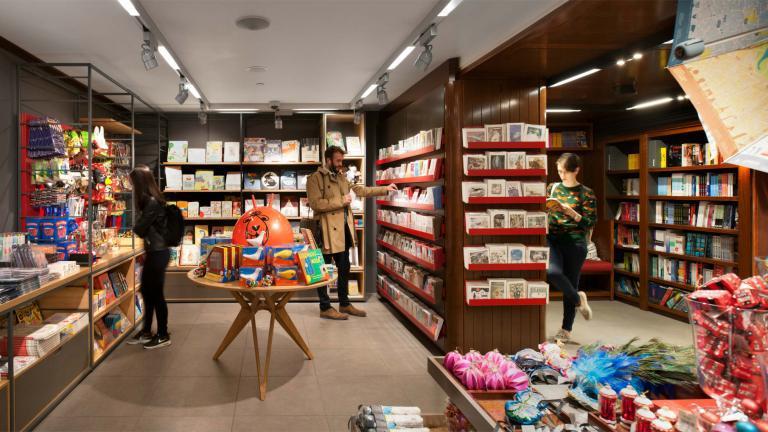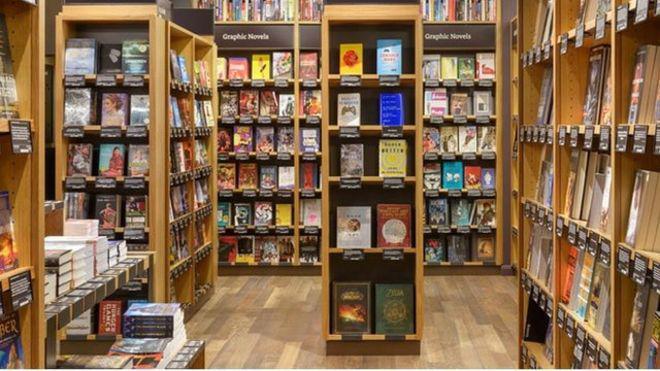The first image is the image on the left, the second image is the image on the right. For the images shown, is this caption "A wall in one image has windows that show a glimpse of outside the bookshop." true? Answer yes or no. No. 